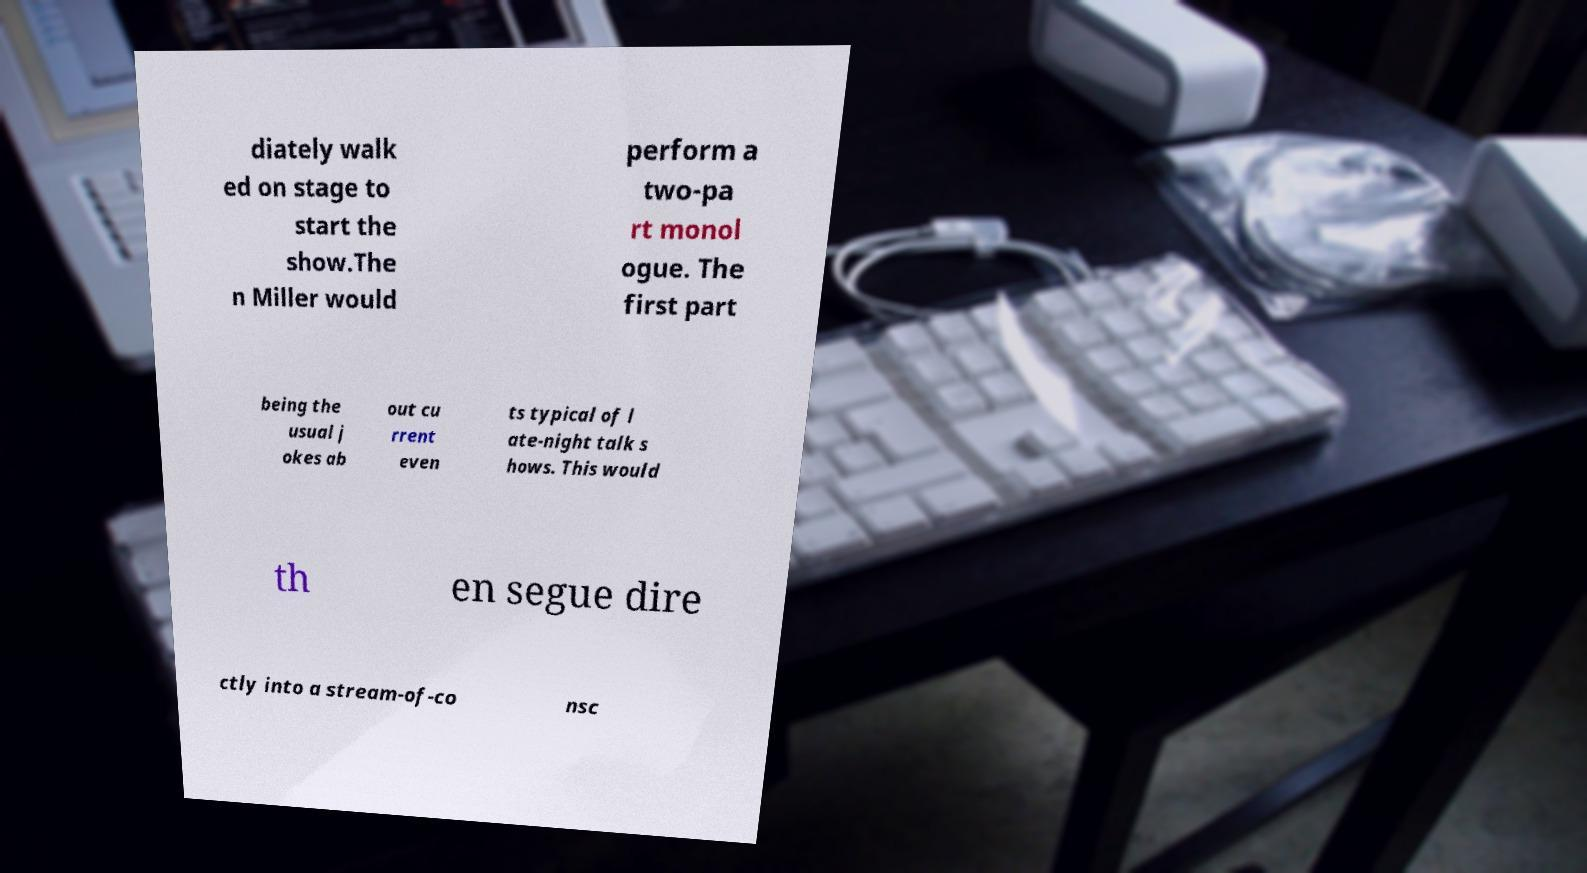I need the written content from this picture converted into text. Can you do that? diately walk ed on stage to start the show.The n Miller would perform a two-pa rt monol ogue. The first part being the usual j okes ab out cu rrent even ts typical of l ate-night talk s hows. This would th en segue dire ctly into a stream-of-co nsc 